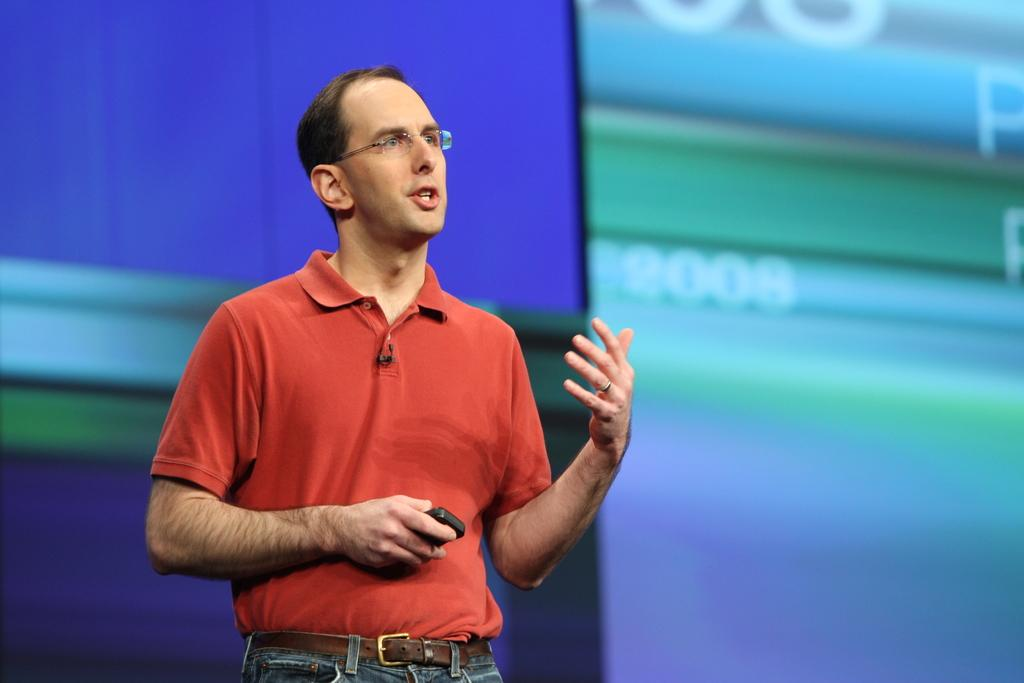Who is the main subject in the image? There is a man in the image. What is the man doing in the image? The man is speaking in the image. What is the man holding in the image? The man is holding a gadget in the image. Can you describe the background of the image? The background of the man is blurred in the image. What type of noise can be heard coming from the trains in the image? There are no trains present in the image, so it's not possible to determine what, if any, noise might be heard. 